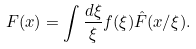Convert formula to latex. <formula><loc_0><loc_0><loc_500><loc_500>F ( x ) = \int \frac { d \xi } { \xi } f ( \xi ) \hat { F } ( x / \xi ) .</formula> 